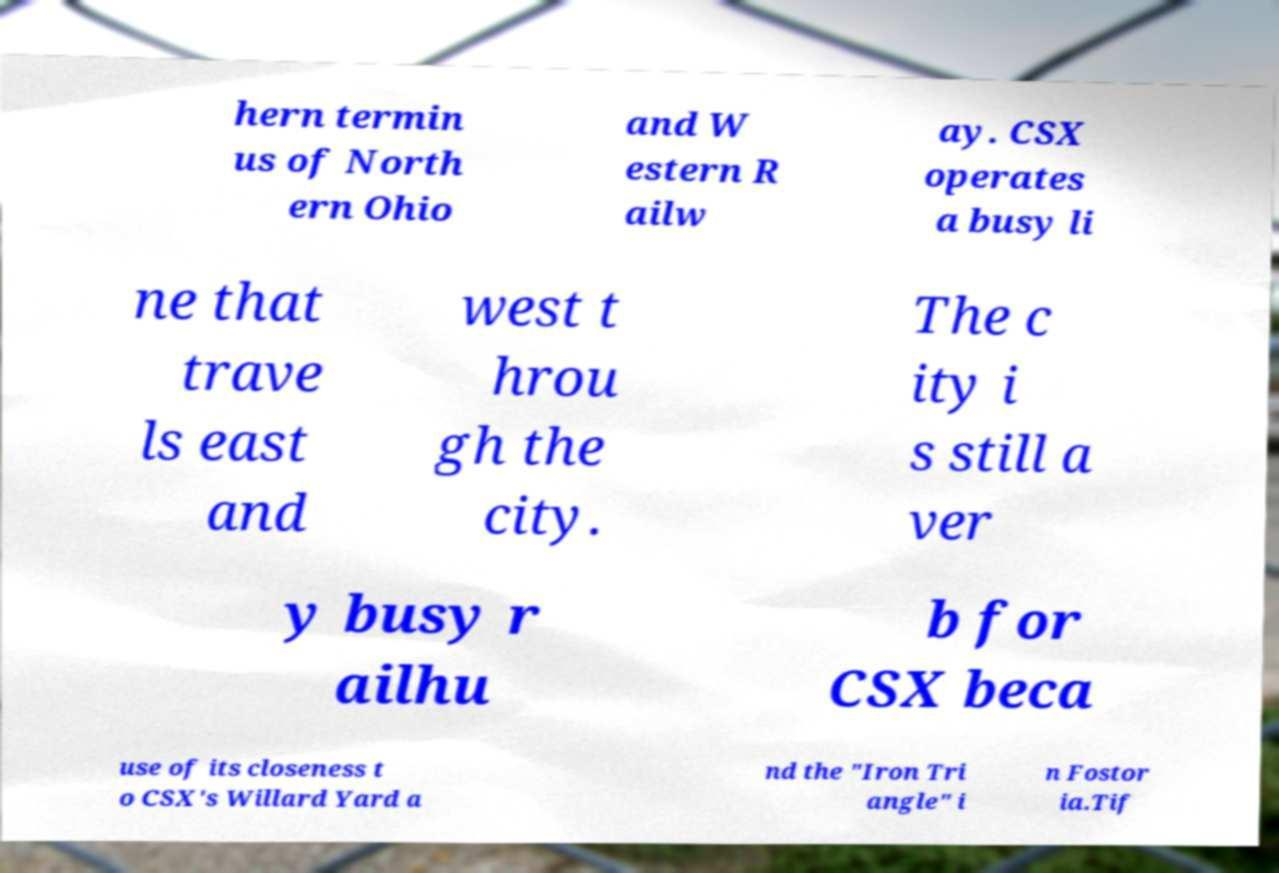Can you read and provide the text displayed in the image?This photo seems to have some interesting text. Can you extract and type it out for me? hern termin us of North ern Ohio and W estern R ailw ay. CSX operates a busy li ne that trave ls east and west t hrou gh the city. The c ity i s still a ver y busy r ailhu b for CSX beca use of its closeness t o CSX's Willard Yard a nd the "Iron Tri angle" i n Fostor ia.Tif 